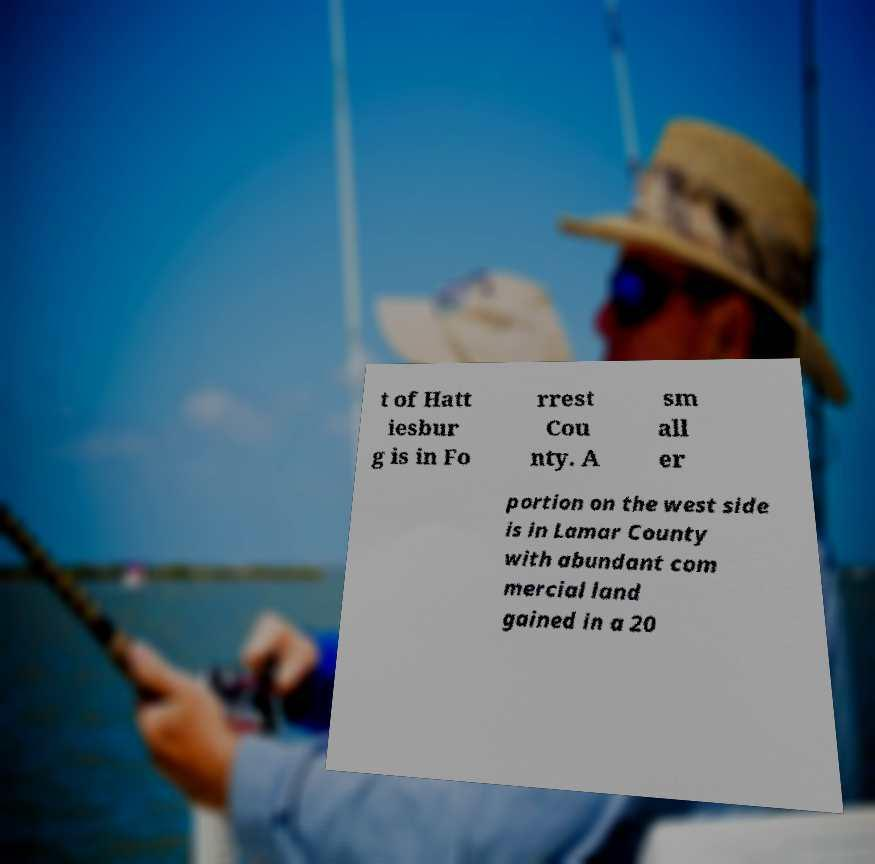I need the written content from this picture converted into text. Can you do that? t of Hatt iesbur g is in Fo rrest Cou nty. A sm all er portion on the west side is in Lamar County with abundant com mercial land gained in a 20 